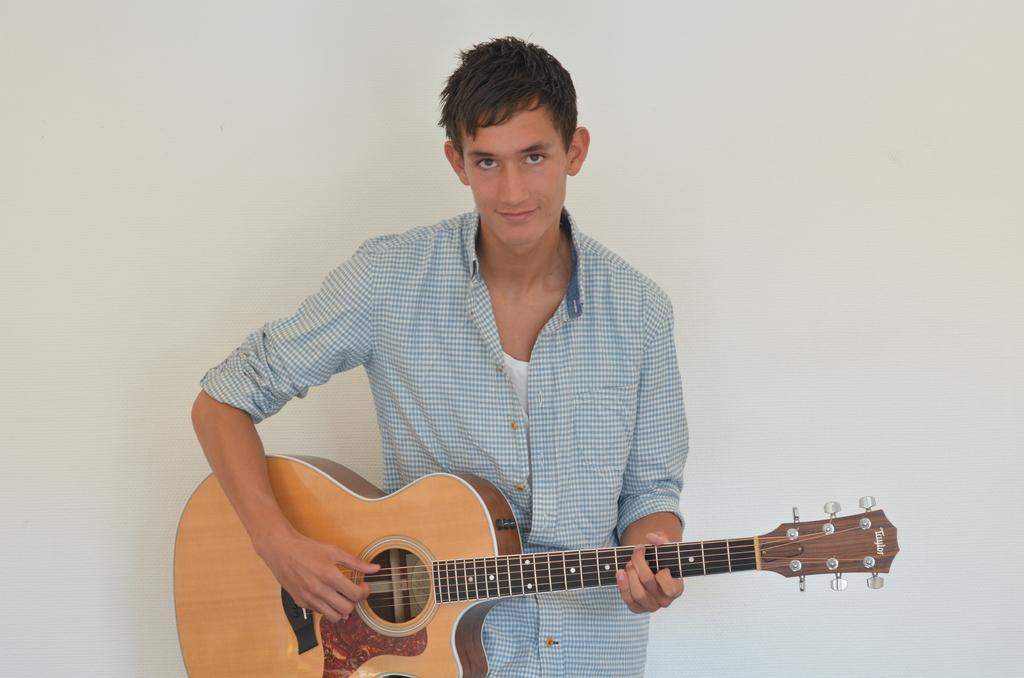What is the main subject of the image? The main subject of the image is a boy. What is the boy wearing in the image? The boy is wearing a checked shirt in the image. What activity is the boy engaged in? The boy is playing a guitar in the image. What type of record is the boy holding in the image? There is no record present in the image; the boy is playing a guitar. 